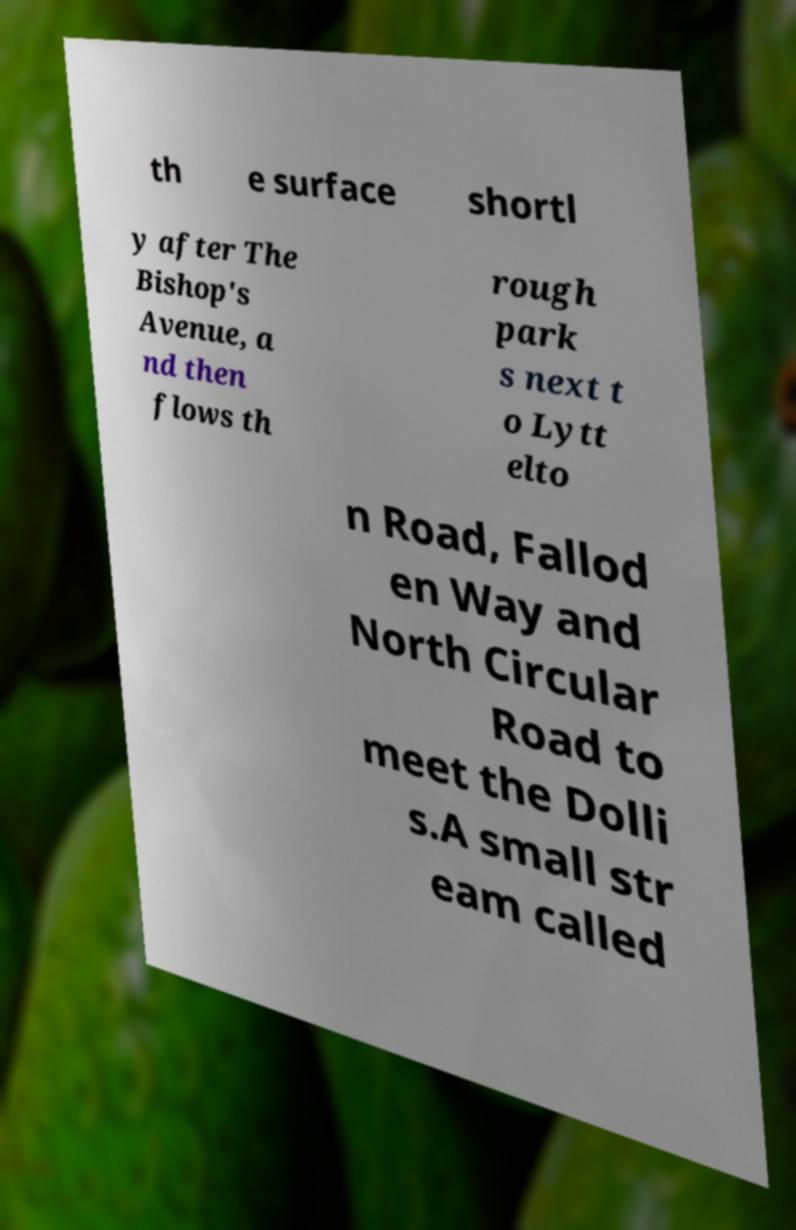Could you assist in decoding the text presented in this image and type it out clearly? th e surface shortl y after The Bishop's Avenue, a nd then flows th rough park s next t o Lytt elto n Road, Fallod en Way and North Circular Road to meet the Dolli s.A small str eam called 